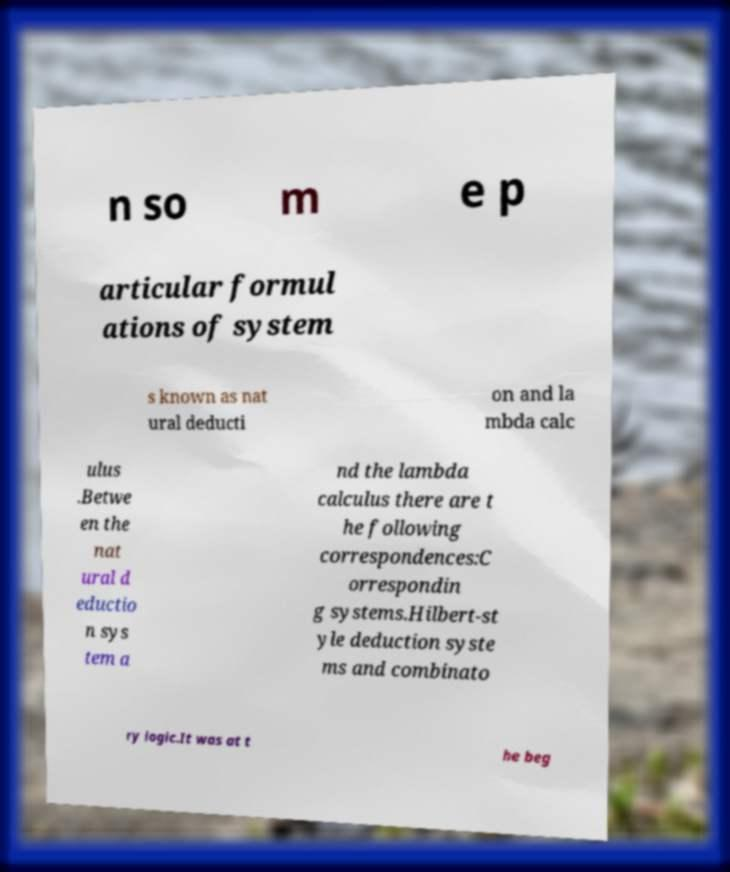Can you accurately transcribe the text from the provided image for me? n so m e p articular formul ations of system s known as nat ural deducti on and la mbda calc ulus .Betwe en the nat ural d eductio n sys tem a nd the lambda calculus there are t he following correspondences:C orrespondin g systems.Hilbert-st yle deduction syste ms and combinato ry logic.It was at t he beg 